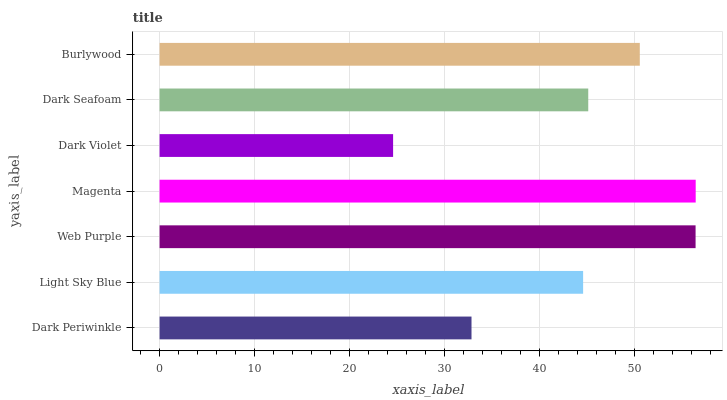Is Dark Violet the minimum?
Answer yes or no. Yes. Is Magenta the maximum?
Answer yes or no. Yes. Is Light Sky Blue the minimum?
Answer yes or no. No. Is Light Sky Blue the maximum?
Answer yes or no. No. Is Light Sky Blue greater than Dark Periwinkle?
Answer yes or no. Yes. Is Dark Periwinkle less than Light Sky Blue?
Answer yes or no. Yes. Is Dark Periwinkle greater than Light Sky Blue?
Answer yes or no. No. Is Light Sky Blue less than Dark Periwinkle?
Answer yes or no. No. Is Dark Seafoam the high median?
Answer yes or no. Yes. Is Dark Seafoam the low median?
Answer yes or no. Yes. Is Magenta the high median?
Answer yes or no. No. Is Light Sky Blue the low median?
Answer yes or no. No. 